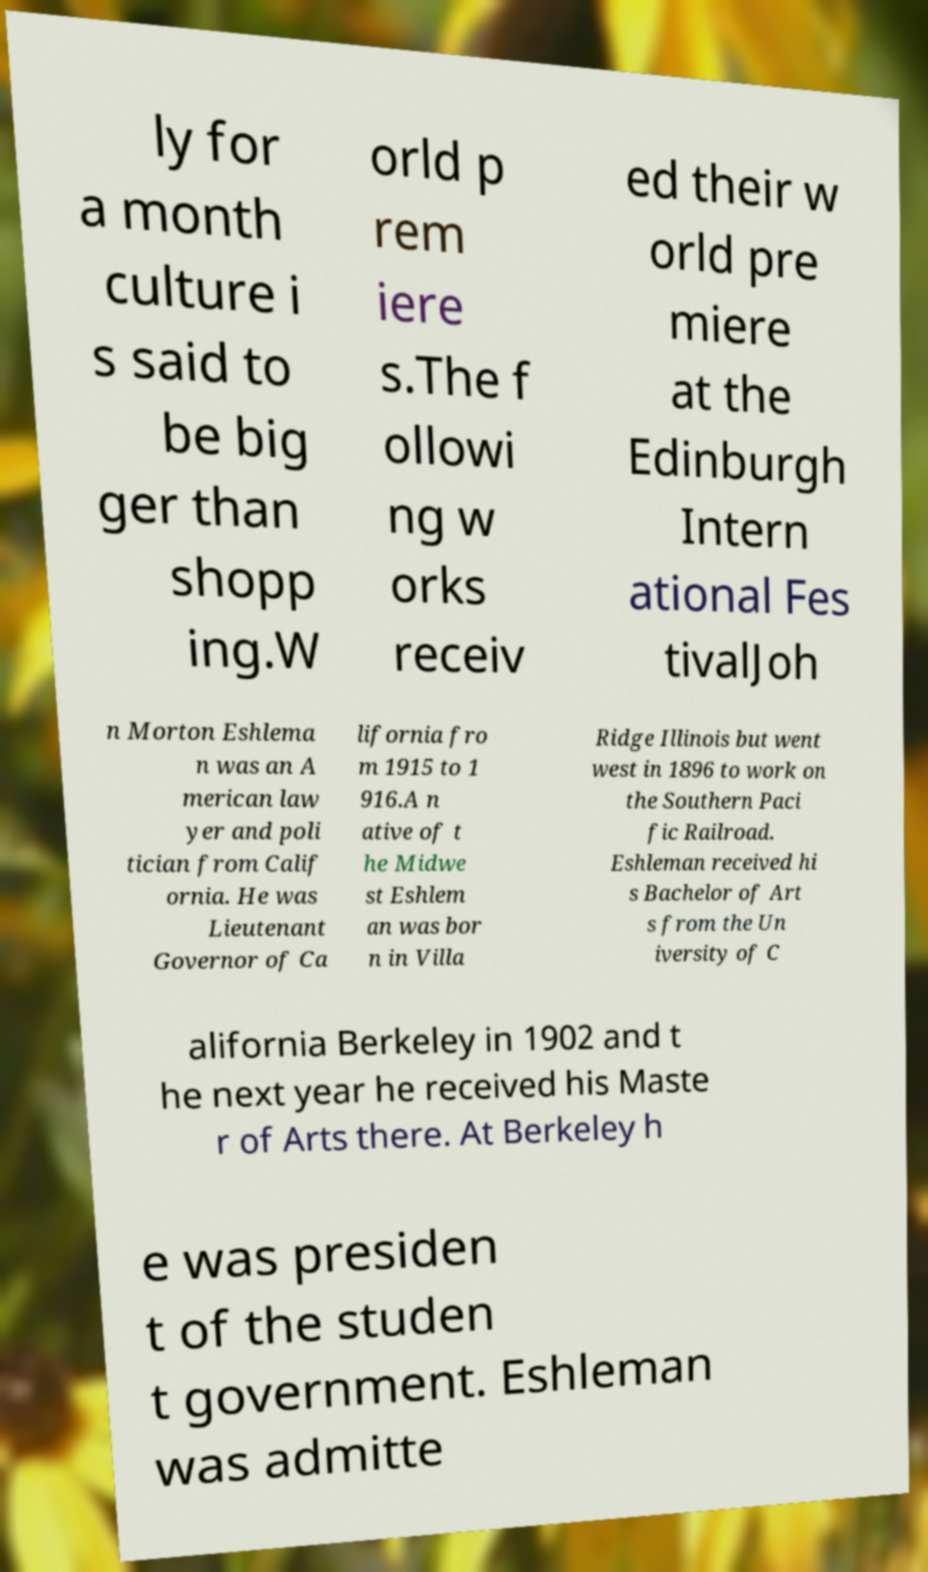What messages or text are displayed in this image? I need them in a readable, typed format. ly for a month culture i s said to be big ger than shopp ing.W orld p rem iere s.The f ollowi ng w orks receiv ed their w orld pre miere at the Edinburgh Intern ational Fes tivalJoh n Morton Eshlema n was an A merican law yer and poli tician from Calif ornia. He was Lieutenant Governor of Ca lifornia fro m 1915 to 1 916.A n ative of t he Midwe st Eshlem an was bor n in Villa Ridge Illinois but went west in 1896 to work on the Southern Paci fic Railroad. Eshleman received hi s Bachelor of Art s from the Un iversity of C alifornia Berkeley in 1902 and t he next year he received his Maste r of Arts there. At Berkeley h e was presiden t of the studen t government. Eshleman was admitte 